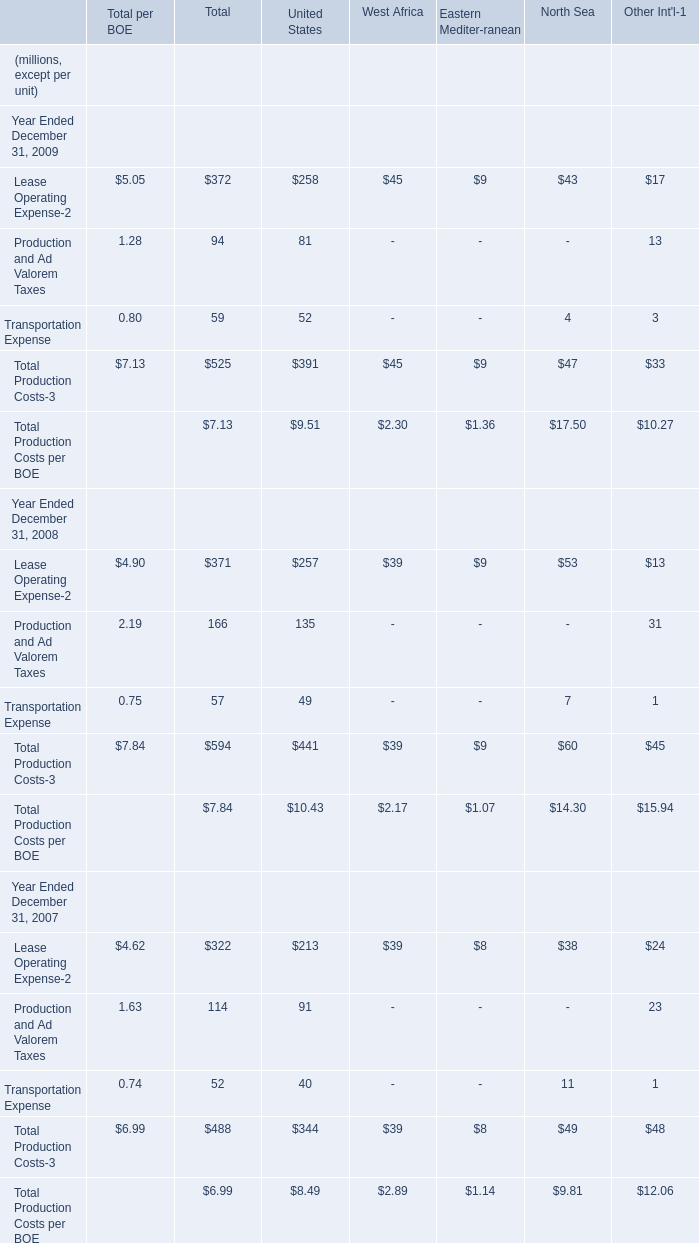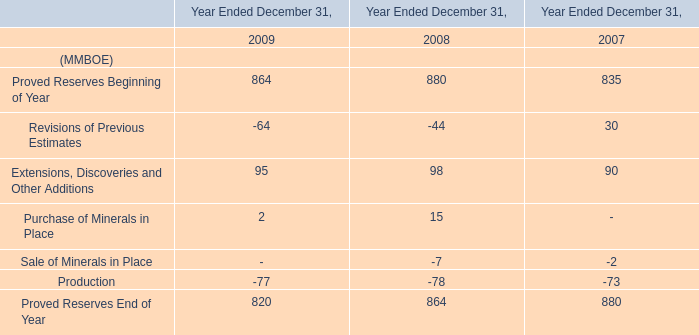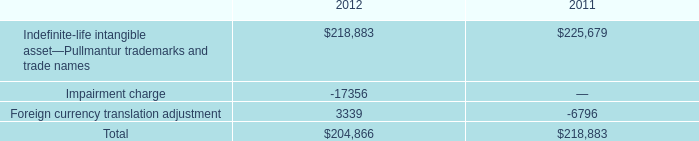The total amount of which section ranks first in Total? 
Answer: Total Production Costs-3. 